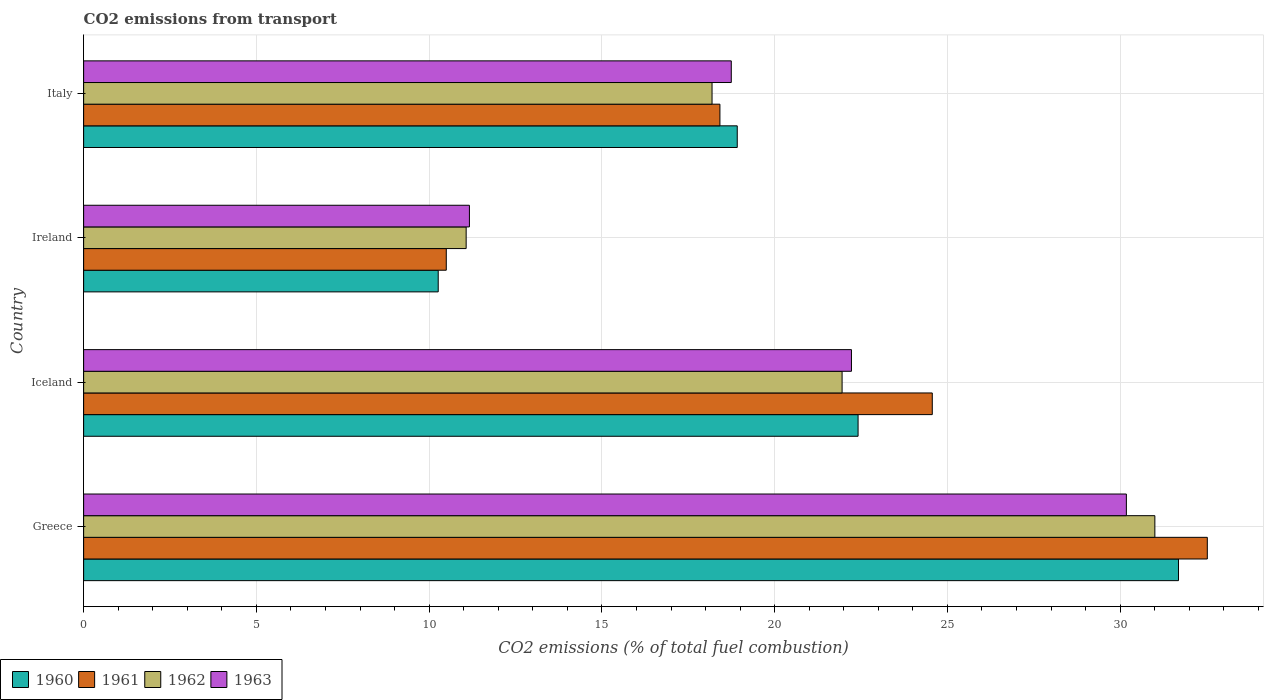How many groups of bars are there?
Your answer should be compact. 4. How many bars are there on the 4th tick from the top?
Ensure brevity in your answer.  4. In how many cases, is the number of bars for a given country not equal to the number of legend labels?
Give a very brief answer. 0. What is the total CO2 emitted in 1962 in Greece?
Your answer should be compact. 31. Across all countries, what is the maximum total CO2 emitted in 1960?
Offer a very short reply. 31.69. Across all countries, what is the minimum total CO2 emitted in 1963?
Your answer should be very brief. 11.17. In which country was the total CO2 emitted in 1962 maximum?
Offer a very short reply. Greece. In which country was the total CO2 emitted in 1962 minimum?
Your answer should be compact. Ireland. What is the total total CO2 emitted in 1960 in the graph?
Provide a succinct answer. 83.28. What is the difference between the total CO2 emitted in 1961 in Iceland and that in Italy?
Ensure brevity in your answer.  6.15. What is the difference between the total CO2 emitted in 1961 in Ireland and the total CO2 emitted in 1962 in Iceland?
Your answer should be compact. -11.46. What is the average total CO2 emitted in 1962 per country?
Make the answer very short. 20.55. What is the difference between the total CO2 emitted in 1961 and total CO2 emitted in 1960 in Ireland?
Ensure brevity in your answer.  0.23. In how many countries, is the total CO2 emitted in 1962 greater than 6 ?
Make the answer very short. 4. What is the ratio of the total CO2 emitted in 1961 in Iceland to that in Italy?
Keep it short and to the point. 1.33. Is the total CO2 emitted in 1960 in Greece less than that in Iceland?
Ensure brevity in your answer.  No. Is the difference between the total CO2 emitted in 1961 in Ireland and Italy greater than the difference between the total CO2 emitted in 1960 in Ireland and Italy?
Offer a terse response. Yes. What is the difference between the highest and the second highest total CO2 emitted in 1963?
Make the answer very short. 7.96. What is the difference between the highest and the lowest total CO2 emitted in 1960?
Provide a succinct answer. 21.42. In how many countries, is the total CO2 emitted in 1961 greater than the average total CO2 emitted in 1961 taken over all countries?
Keep it short and to the point. 2. Is the sum of the total CO2 emitted in 1962 in Greece and Italy greater than the maximum total CO2 emitted in 1961 across all countries?
Keep it short and to the point. Yes. Is it the case that in every country, the sum of the total CO2 emitted in 1963 and total CO2 emitted in 1962 is greater than the sum of total CO2 emitted in 1961 and total CO2 emitted in 1960?
Ensure brevity in your answer.  No. Is it the case that in every country, the sum of the total CO2 emitted in 1963 and total CO2 emitted in 1960 is greater than the total CO2 emitted in 1961?
Provide a short and direct response. Yes. How many bars are there?
Provide a short and direct response. 16. Are all the bars in the graph horizontal?
Make the answer very short. Yes. What is the difference between two consecutive major ticks on the X-axis?
Your answer should be compact. 5. Are the values on the major ticks of X-axis written in scientific E-notation?
Your answer should be compact. No. Does the graph contain grids?
Provide a succinct answer. Yes. Where does the legend appear in the graph?
Give a very brief answer. Bottom left. How many legend labels are there?
Ensure brevity in your answer.  4. What is the title of the graph?
Offer a terse response. CO2 emissions from transport. Does "1971" appear as one of the legend labels in the graph?
Make the answer very short. No. What is the label or title of the X-axis?
Ensure brevity in your answer.  CO2 emissions (% of total fuel combustion). What is the label or title of the Y-axis?
Offer a terse response. Country. What is the CO2 emissions (% of total fuel combustion) in 1960 in Greece?
Ensure brevity in your answer.  31.69. What is the CO2 emissions (% of total fuel combustion) of 1961 in Greece?
Give a very brief answer. 32.52. What is the CO2 emissions (% of total fuel combustion) of 1962 in Greece?
Keep it short and to the point. 31. What is the CO2 emissions (% of total fuel combustion) of 1963 in Greece?
Provide a short and direct response. 30.18. What is the CO2 emissions (% of total fuel combustion) in 1960 in Iceland?
Provide a succinct answer. 22.41. What is the CO2 emissions (% of total fuel combustion) of 1961 in Iceland?
Your response must be concise. 24.56. What is the CO2 emissions (% of total fuel combustion) in 1962 in Iceland?
Provide a short and direct response. 21.95. What is the CO2 emissions (% of total fuel combustion) in 1963 in Iceland?
Keep it short and to the point. 22.22. What is the CO2 emissions (% of total fuel combustion) in 1960 in Ireland?
Offer a very short reply. 10.26. What is the CO2 emissions (% of total fuel combustion) of 1961 in Ireland?
Ensure brevity in your answer.  10.5. What is the CO2 emissions (% of total fuel combustion) in 1962 in Ireland?
Provide a succinct answer. 11.07. What is the CO2 emissions (% of total fuel combustion) in 1963 in Ireland?
Your response must be concise. 11.17. What is the CO2 emissions (% of total fuel combustion) of 1960 in Italy?
Give a very brief answer. 18.92. What is the CO2 emissions (% of total fuel combustion) in 1961 in Italy?
Your answer should be compact. 18.42. What is the CO2 emissions (% of total fuel combustion) of 1962 in Italy?
Provide a succinct answer. 18.19. What is the CO2 emissions (% of total fuel combustion) of 1963 in Italy?
Your answer should be compact. 18.74. Across all countries, what is the maximum CO2 emissions (% of total fuel combustion) in 1960?
Ensure brevity in your answer.  31.69. Across all countries, what is the maximum CO2 emissions (% of total fuel combustion) of 1961?
Keep it short and to the point. 32.52. Across all countries, what is the maximum CO2 emissions (% of total fuel combustion) in 1962?
Provide a short and direct response. 31. Across all countries, what is the maximum CO2 emissions (% of total fuel combustion) of 1963?
Your answer should be very brief. 30.18. Across all countries, what is the minimum CO2 emissions (% of total fuel combustion) of 1960?
Your response must be concise. 10.26. Across all countries, what is the minimum CO2 emissions (% of total fuel combustion) of 1961?
Make the answer very short. 10.5. Across all countries, what is the minimum CO2 emissions (% of total fuel combustion) of 1962?
Your response must be concise. 11.07. Across all countries, what is the minimum CO2 emissions (% of total fuel combustion) of 1963?
Keep it short and to the point. 11.17. What is the total CO2 emissions (% of total fuel combustion) in 1960 in the graph?
Provide a succinct answer. 83.28. What is the total CO2 emissions (% of total fuel combustion) of 1961 in the graph?
Offer a very short reply. 85.99. What is the total CO2 emissions (% of total fuel combustion) in 1962 in the graph?
Make the answer very short. 82.21. What is the total CO2 emissions (% of total fuel combustion) in 1963 in the graph?
Ensure brevity in your answer.  82.31. What is the difference between the CO2 emissions (% of total fuel combustion) of 1960 in Greece and that in Iceland?
Offer a very short reply. 9.27. What is the difference between the CO2 emissions (% of total fuel combustion) in 1961 in Greece and that in Iceland?
Provide a short and direct response. 7.96. What is the difference between the CO2 emissions (% of total fuel combustion) in 1962 in Greece and that in Iceland?
Make the answer very short. 9.05. What is the difference between the CO2 emissions (% of total fuel combustion) of 1963 in Greece and that in Iceland?
Provide a short and direct response. 7.96. What is the difference between the CO2 emissions (% of total fuel combustion) of 1960 in Greece and that in Ireland?
Your answer should be very brief. 21.42. What is the difference between the CO2 emissions (% of total fuel combustion) in 1961 in Greece and that in Ireland?
Offer a very short reply. 22.03. What is the difference between the CO2 emissions (% of total fuel combustion) in 1962 in Greece and that in Ireland?
Provide a short and direct response. 19.93. What is the difference between the CO2 emissions (% of total fuel combustion) in 1963 in Greece and that in Ireland?
Keep it short and to the point. 19.01. What is the difference between the CO2 emissions (% of total fuel combustion) of 1960 in Greece and that in Italy?
Give a very brief answer. 12.77. What is the difference between the CO2 emissions (% of total fuel combustion) of 1961 in Greece and that in Italy?
Give a very brief answer. 14.11. What is the difference between the CO2 emissions (% of total fuel combustion) in 1962 in Greece and that in Italy?
Make the answer very short. 12.82. What is the difference between the CO2 emissions (% of total fuel combustion) in 1963 in Greece and that in Italy?
Your response must be concise. 11.43. What is the difference between the CO2 emissions (% of total fuel combustion) in 1960 in Iceland and that in Ireland?
Keep it short and to the point. 12.15. What is the difference between the CO2 emissions (% of total fuel combustion) of 1961 in Iceland and that in Ireland?
Provide a succinct answer. 14.07. What is the difference between the CO2 emissions (% of total fuel combustion) of 1962 in Iceland and that in Ireland?
Your response must be concise. 10.88. What is the difference between the CO2 emissions (% of total fuel combustion) in 1963 in Iceland and that in Ireland?
Provide a short and direct response. 11.06. What is the difference between the CO2 emissions (% of total fuel combustion) in 1960 in Iceland and that in Italy?
Make the answer very short. 3.5. What is the difference between the CO2 emissions (% of total fuel combustion) of 1961 in Iceland and that in Italy?
Offer a very short reply. 6.15. What is the difference between the CO2 emissions (% of total fuel combustion) of 1962 in Iceland and that in Italy?
Your answer should be very brief. 3.76. What is the difference between the CO2 emissions (% of total fuel combustion) of 1963 in Iceland and that in Italy?
Provide a short and direct response. 3.48. What is the difference between the CO2 emissions (% of total fuel combustion) in 1960 in Ireland and that in Italy?
Make the answer very short. -8.65. What is the difference between the CO2 emissions (% of total fuel combustion) in 1961 in Ireland and that in Italy?
Provide a succinct answer. -7.92. What is the difference between the CO2 emissions (% of total fuel combustion) of 1962 in Ireland and that in Italy?
Keep it short and to the point. -7.12. What is the difference between the CO2 emissions (% of total fuel combustion) of 1963 in Ireland and that in Italy?
Offer a very short reply. -7.58. What is the difference between the CO2 emissions (% of total fuel combustion) in 1960 in Greece and the CO2 emissions (% of total fuel combustion) in 1961 in Iceland?
Keep it short and to the point. 7.13. What is the difference between the CO2 emissions (% of total fuel combustion) of 1960 in Greece and the CO2 emissions (% of total fuel combustion) of 1962 in Iceland?
Your response must be concise. 9.74. What is the difference between the CO2 emissions (% of total fuel combustion) of 1960 in Greece and the CO2 emissions (% of total fuel combustion) of 1963 in Iceland?
Ensure brevity in your answer.  9.46. What is the difference between the CO2 emissions (% of total fuel combustion) in 1961 in Greece and the CO2 emissions (% of total fuel combustion) in 1962 in Iceland?
Ensure brevity in your answer.  10.57. What is the difference between the CO2 emissions (% of total fuel combustion) of 1961 in Greece and the CO2 emissions (% of total fuel combustion) of 1963 in Iceland?
Provide a succinct answer. 10.3. What is the difference between the CO2 emissions (% of total fuel combustion) in 1962 in Greece and the CO2 emissions (% of total fuel combustion) in 1963 in Iceland?
Offer a terse response. 8.78. What is the difference between the CO2 emissions (% of total fuel combustion) in 1960 in Greece and the CO2 emissions (% of total fuel combustion) in 1961 in Ireland?
Provide a short and direct response. 21.19. What is the difference between the CO2 emissions (% of total fuel combustion) of 1960 in Greece and the CO2 emissions (% of total fuel combustion) of 1962 in Ireland?
Keep it short and to the point. 20.62. What is the difference between the CO2 emissions (% of total fuel combustion) of 1960 in Greece and the CO2 emissions (% of total fuel combustion) of 1963 in Ireland?
Ensure brevity in your answer.  20.52. What is the difference between the CO2 emissions (% of total fuel combustion) of 1961 in Greece and the CO2 emissions (% of total fuel combustion) of 1962 in Ireland?
Your response must be concise. 21.45. What is the difference between the CO2 emissions (% of total fuel combustion) in 1961 in Greece and the CO2 emissions (% of total fuel combustion) in 1963 in Ireland?
Offer a very short reply. 21.36. What is the difference between the CO2 emissions (% of total fuel combustion) of 1962 in Greece and the CO2 emissions (% of total fuel combustion) of 1963 in Ireland?
Give a very brief answer. 19.84. What is the difference between the CO2 emissions (% of total fuel combustion) of 1960 in Greece and the CO2 emissions (% of total fuel combustion) of 1961 in Italy?
Your answer should be very brief. 13.27. What is the difference between the CO2 emissions (% of total fuel combustion) in 1960 in Greece and the CO2 emissions (% of total fuel combustion) in 1962 in Italy?
Provide a succinct answer. 13.5. What is the difference between the CO2 emissions (% of total fuel combustion) of 1960 in Greece and the CO2 emissions (% of total fuel combustion) of 1963 in Italy?
Provide a succinct answer. 12.94. What is the difference between the CO2 emissions (% of total fuel combustion) in 1961 in Greece and the CO2 emissions (% of total fuel combustion) in 1962 in Italy?
Ensure brevity in your answer.  14.33. What is the difference between the CO2 emissions (% of total fuel combustion) in 1961 in Greece and the CO2 emissions (% of total fuel combustion) in 1963 in Italy?
Your response must be concise. 13.78. What is the difference between the CO2 emissions (% of total fuel combustion) of 1962 in Greece and the CO2 emissions (% of total fuel combustion) of 1963 in Italy?
Keep it short and to the point. 12.26. What is the difference between the CO2 emissions (% of total fuel combustion) in 1960 in Iceland and the CO2 emissions (% of total fuel combustion) in 1961 in Ireland?
Make the answer very short. 11.92. What is the difference between the CO2 emissions (% of total fuel combustion) in 1960 in Iceland and the CO2 emissions (% of total fuel combustion) in 1962 in Ireland?
Provide a short and direct response. 11.34. What is the difference between the CO2 emissions (% of total fuel combustion) of 1960 in Iceland and the CO2 emissions (% of total fuel combustion) of 1963 in Ireland?
Your response must be concise. 11.25. What is the difference between the CO2 emissions (% of total fuel combustion) in 1961 in Iceland and the CO2 emissions (% of total fuel combustion) in 1962 in Ireland?
Offer a terse response. 13.49. What is the difference between the CO2 emissions (% of total fuel combustion) of 1961 in Iceland and the CO2 emissions (% of total fuel combustion) of 1963 in Ireland?
Your answer should be very brief. 13.4. What is the difference between the CO2 emissions (% of total fuel combustion) of 1962 in Iceland and the CO2 emissions (% of total fuel combustion) of 1963 in Ireland?
Your answer should be very brief. 10.79. What is the difference between the CO2 emissions (% of total fuel combustion) of 1960 in Iceland and the CO2 emissions (% of total fuel combustion) of 1961 in Italy?
Give a very brief answer. 4. What is the difference between the CO2 emissions (% of total fuel combustion) of 1960 in Iceland and the CO2 emissions (% of total fuel combustion) of 1962 in Italy?
Your answer should be very brief. 4.23. What is the difference between the CO2 emissions (% of total fuel combustion) of 1960 in Iceland and the CO2 emissions (% of total fuel combustion) of 1963 in Italy?
Ensure brevity in your answer.  3.67. What is the difference between the CO2 emissions (% of total fuel combustion) in 1961 in Iceland and the CO2 emissions (% of total fuel combustion) in 1962 in Italy?
Your response must be concise. 6.37. What is the difference between the CO2 emissions (% of total fuel combustion) in 1961 in Iceland and the CO2 emissions (% of total fuel combustion) in 1963 in Italy?
Offer a very short reply. 5.82. What is the difference between the CO2 emissions (% of total fuel combustion) in 1962 in Iceland and the CO2 emissions (% of total fuel combustion) in 1963 in Italy?
Your answer should be compact. 3.21. What is the difference between the CO2 emissions (% of total fuel combustion) in 1960 in Ireland and the CO2 emissions (% of total fuel combustion) in 1961 in Italy?
Give a very brief answer. -8.15. What is the difference between the CO2 emissions (% of total fuel combustion) of 1960 in Ireland and the CO2 emissions (% of total fuel combustion) of 1962 in Italy?
Keep it short and to the point. -7.92. What is the difference between the CO2 emissions (% of total fuel combustion) of 1960 in Ireland and the CO2 emissions (% of total fuel combustion) of 1963 in Italy?
Offer a very short reply. -8.48. What is the difference between the CO2 emissions (% of total fuel combustion) of 1961 in Ireland and the CO2 emissions (% of total fuel combustion) of 1962 in Italy?
Your response must be concise. -7.69. What is the difference between the CO2 emissions (% of total fuel combustion) in 1961 in Ireland and the CO2 emissions (% of total fuel combustion) in 1963 in Italy?
Provide a succinct answer. -8.25. What is the difference between the CO2 emissions (% of total fuel combustion) of 1962 in Ireland and the CO2 emissions (% of total fuel combustion) of 1963 in Italy?
Offer a terse response. -7.67. What is the average CO2 emissions (% of total fuel combustion) in 1960 per country?
Make the answer very short. 20.82. What is the average CO2 emissions (% of total fuel combustion) in 1961 per country?
Keep it short and to the point. 21.5. What is the average CO2 emissions (% of total fuel combustion) of 1962 per country?
Offer a terse response. 20.55. What is the average CO2 emissions (% of total fuel combustion) in 1963 per country?
Keep it short and to the point. 20.58. What is the difference between the CO2 emissions (% of total fuel combustion) of 1960 and CO2 emissions (% of total fuel combustion) of 1961 in Greece?
Keep it short and to the point. -0.83. What is the difference between the CO2 emissions (% of total fuel combustion) of 1960 and CO2 emissions (% of total fuel combustion) of 1962 in Greece?
Offer a terse response. 0.68. What is the difference between the CO2 emissions (% of total fuel combustion) of 1960 and CO2 emissions (% of total fuel combustion) of 1963 in Greece?
Offer a very short reply. 1.51. What is the difference between the CO2 emissions (% of total fuel combustion) of 1961 and CO2 emissions (% of total fuel combustion) of 1962 in Greece?
Offer a very short reply. 1.52. What is the difference between the CO2 emissions (% of total fuel combustion) in 1961 and CO2 emissions (% of total fuel combustion) in 1963 in Greece?
Ensure brevity in your answer.  2.34. What is the difference between the CO2 emissions (% of total fuel combustion) in 1962 and CO2 emissions (% of total fuel combustion) in 1963 in Greece?
Your answer should be compact. 0.82. What is the difference between the CO2 emissions (% of total fuel combustion) of 1960 and CO2 emissions (% of total fuel combustion) of 1961 in Iceland?
Ensure brevity in your answer.  -2.15. What is the difference between the CO2 emissions (% of total fuel combustion) in 1960 and CO2 emissions (% of total fuel combustion) in 1962 in Iceland?
Your response must be concise. 0.46. What is the difference between the CO2 emissions (% of total fuel combustion) in 1960 and CO2 emissions (% of total fuel combustion) in 1963 in Iceland?
Give a very brief answer. 0.19. What is the difference between the CO2 emissions (% of total fuel combustion) in 1961 and CO2 emissions (% of total fuel combustion) in 1962 in Iceland?
Provide a succinct answer. 2.61. What is the difference between the CO2 emissions (% of total fuel combustion) in 1961 and CO2 emissions (% of total fuel combustion) in 1963 in Iceland?
Your answer should be compact. 2.34. What is the difference between the CO2 emissions (% of total fuel combustion) of 1962 and CO2 emissions (% of total fuel combustion) of 1963 in Iceland?
Ensure brevity in your answer.  -0.27. What is the difference between the CO2 emissions (% of total fuel combustion) in 1960 and CO2 emissions (% of total fuel combustion) in 1961 in Ireland?
Provide a succinct answer. -0.23. What is the difference between the CO2 emissions (% of total fuel combustion) of 1960 and CO2 emissions (% of total fuel combustion) of 1962 in Ireland?
Offer a terse response. -0.81. What is the difference between the CO2 emissions (% of total fuel combustion) in 1960 and CO2 emissions (% of total fuel combustion) in 1963 in Ireland?
Provide a succinct answer. -0.9. What is the difference between the CO2 emissions (% of total fuel combustion) in 1961 and CO2 emissions (% of total fuel combustion) in 1962 in Ireland?
Keep it short and to the point. -0.58. What is the difference between the CO2 emissions (% of total fuel combustion) of 1961 and CO2 emissions (% of total fuel combustion) of 1963 in Ireland?
Your answer should be very brief. -0.67. What is the difference between the CO2 emissions (% of total fuel combustion) of 1962 and CO2 emissions (% of total fuel combustion) of 1963 in Ireland?
Make the answer very short. -0.09. What is the difference between the CO2 emissions (% of total fuel combustion) in 1960 and CO2 emissions (% of total fuel combustion) in 1961 in Italy?
Ensure brevity in your answer.  0.5. What is the difference between the CO2 emissions (% of total fuel combustion) in 1960 and CO2 emissions (% of total fuel combustion) in 1962 in Italy?
Give a very brief answer. 0.73. What is the difference between the CO2 emissions (% of total fuel combustion) in 1960 and CO2 emissions (% of total fuel combustion) in 1963 in Italy?
Ensure brevity in your answer.  0.17. What is the difference between the CO2 emissions (% of total fuel combustion) in 1961 and CO2 emissions (% of total fuel combustion) in 1962 in Italy?
Your answer should be very brief. 0.23. What is the difference between the CO2 emissions (% of total fuel combustion) in 1961 and CO2 emissions (% of total fuel combustion) in 1963 in Italy?
Offer a terse response. -0.33. What is the difference between the CO2 emissions (% of total fuel combustion) in 1962 and CO2 emissions (% of total fuel combustion) in 1963 in Italy?
Your response must be concise. -0.56. What is the ratio of the CO2 emissions (% of total fuel combustion) in 1960 in Greece to that in Iceland?
Your response must be concise. 1.41. What is the ratio of the CO2 emissions (% of total fuel combustion) of 1961 in Greece to that in Iceland?
Provide a succinct answer. 1.32. What is the ratio of the CO2 emissions (% of total fuel combustion) of 1962 in Greece to that in Iceland?
Your answer should be very brief. 1.41. What is the ratio of the CO2 emissions (% of total fuel combustion) in 1963 in Greece to that in Iceland?
Keep it short and to the point. 1.36. What is the ratio of the CO2 emissions (% of total fuel combustion) of 1960 in Greece to that in Ireland?
Offer a very short reply. 3.09. What is the ratio of the CO2 emissions (% of total fuel combustion) in 1961 in Greece to that in Ireland?
Give a very brief answer. 3.1. What is the ratio of the CO2 emissions (% of total fuel combustion) of 1962 in Greece to that in Ireland?
Your answer should be very brief. 2.8. What is the ratio of the CO2 emissions (% of total fuel combustion) of 1963 in Greece to that in Ireland?
Give a very brief answer. 2.7. What is the ratio of the CO2 emissions (% of total fuel combustion) of 1960 in Greece to that in Italy?
Your answer should be compact. 1.68. What is the ratio of the CO2 emissions (% of total fuel combustion) in 1961 in Greece to that in Italy?
Give a very brief answer. 1.77. What is the ratio of the CO2 emissions (% of total fuel combustion) of 1962 in Greece to that in Italy?
Your answer should be very brief. 1.7. What is the ratio of the CO2 emissions (% of total fuel combustion) in 1963 in Greece to that in Italy?
Keep it short and to the point. 1.61. What is the ratio of the CO2 emissions (% of total fuel combustion) of 1960 in Iceland to that in Ireland?
Offer a terse response. 2.18. What is the ratio of the CO2 emissions (% of total fuel combustion) in 1961 in Iceland to that in Ireland?
Provide a succinct answer. 2.34. What is the ratio of the CO2 emissions (% of total fuel combustion) of 1962 in Iceland to that in Ireland?
Provide a short and direct response. 1.98. What is the ratio of the CO2 emissions (% of total fuel combustion) of 1963 in Iceland to that in Ireland?
Keep it short and to the point. 1.99. What is the ratio of the CO2 emissions (% of total fuel combustion) in 1960 in Iceland to that in Italy?
Your response must be concise. 1.18. What is the ratio of the CO2 emissions (% of total fuel combustion) in 1961 in Iceland to that in Italy?
Keep it short and to the point. 1.33. What is the ratio of the CO2 emissions (% of total fuel combustion) in 1962 in Iceland to that in Italy?
Offer a terse response. 1.21. What is the ratio of the CO2 emissions (% of total fuel combustion) of 1963 in Iceland to that in Italy?
Your answer should be very brief. 1.19. What is the ratio of the CO2 emissions (% of total fuel combustion) in 1960 in Ireland to that in Italy?
Provide a succinct answer. 0.54. What is the ratio of the CO2 emissions (% of total fuel combustion) in 1961 in Ireland to that in Italy?
Offer a terse response. 0.57. What is the ratio of the CO2 emissions (% of total fuel combustion) in 1962 in Ireland to that in Italy?
Your answer should be compact. 0.61. What is the ratio of the CO2 emissions (% of total fuel combustion) in 1963 in Ireland to that in Italy?
Your answer should be compact. 0.6. What is the difference between the highest and the second highest CO2 emissions (% of total fuel combustion) in 1960?
Make the answer very short. 9.27. What is the difference between the highest and the second highest CO2 emissions (% of total fuel combustion) in 1961?
Keep it short and to the point. 7.96. What is the difference between the highest and the second highest CO2 emissions (% of total fuel combustion) in 1962?
Keep it short and to the point. 9.05. What is the difference between the highest and the second highest CO2 emissions (% of total fuel combustion) of 1963?
Your response must be concise. 7.96. What is the difference between the highest and the lowest CO2 emissions (% of total fuel combustion) in 1960?
Your answer should be compact. 21.42. What is the difference between the highest and the lowest CO2 emissions (% of total fuel combustion) of 1961?
Your response must be concise. 22.03. What is the difference between the highest and the lowest CO2 emissions (% of total fuel combustion) in 1962?
Offer a very short reply. 19.93. What is the difference between the highest and the lowest CO2 emissions (% of total fuel combustion) in 1963?
Make the answer very short. 19.01. 